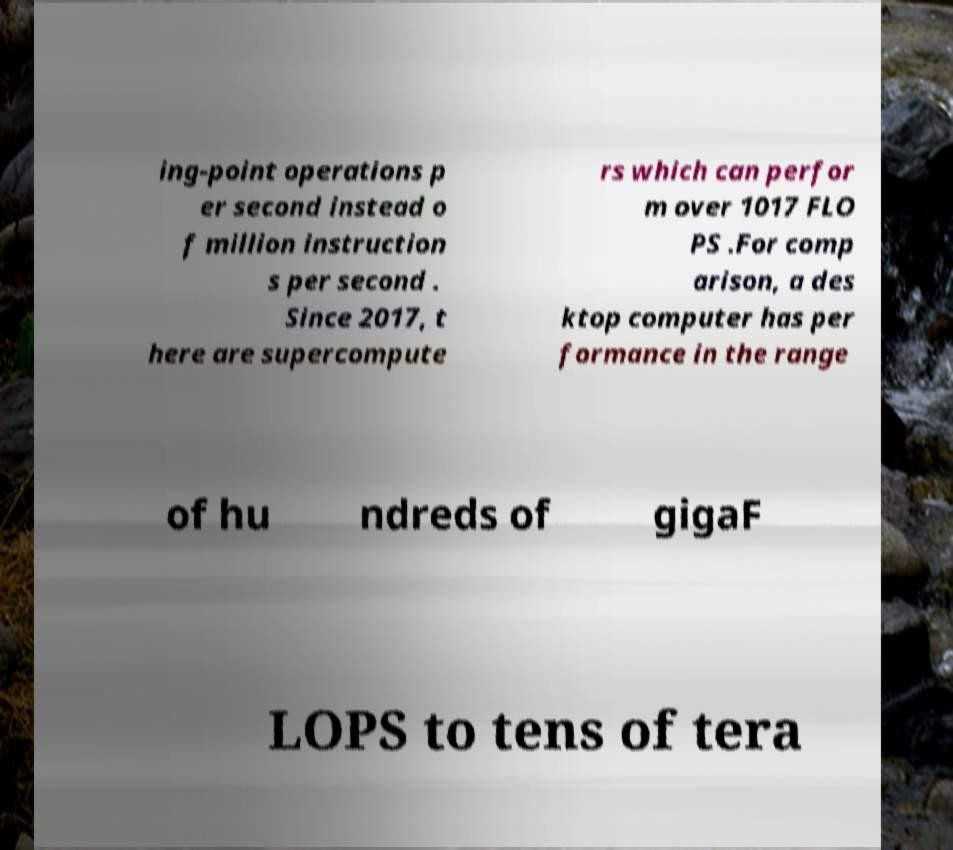There's text embedded in this image that I need extracted. Can you transcribe it verbatim? ing-point operations p er second instead o f million instruction s per second . Since 2017, t here are supercompute rs which can perfor m over 1017 FLO PS .For comp arison, a des ktop computer has per formance in the range of hu ndreds of gigaF LOPS to tens of tera 